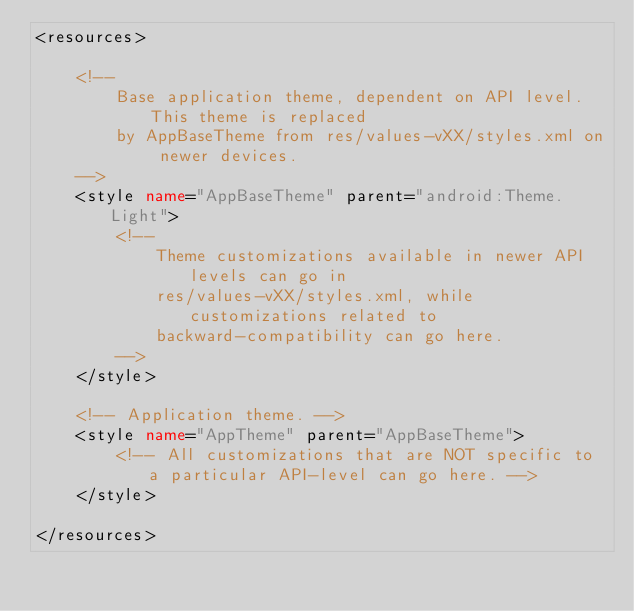<code> <loc_0><loc_0><loc_500><loc_500><_XML_><resources>

    <!--
        Base application theme, dependent on API level. This theme is replaced
        by AppBaseTheme from res/values-vXX/styles.xml on newer devices.
    -->
    <style name="AppBaseTheme" parent="android:Theme.Light">
        <!--
            Theme customizations available in newer API levels can go in
            res/values-vXX/styles.xml, while customizations related to
            backward-compatibility can go here.
        -->
    </style>

    <!-- Application theme. -->
    <style name="AppTheme" parent="AppBaseTheme">
        <!-- All customizations that are NOT specific to a particular API-level can go here. -->
    </style>

</resources></code> 